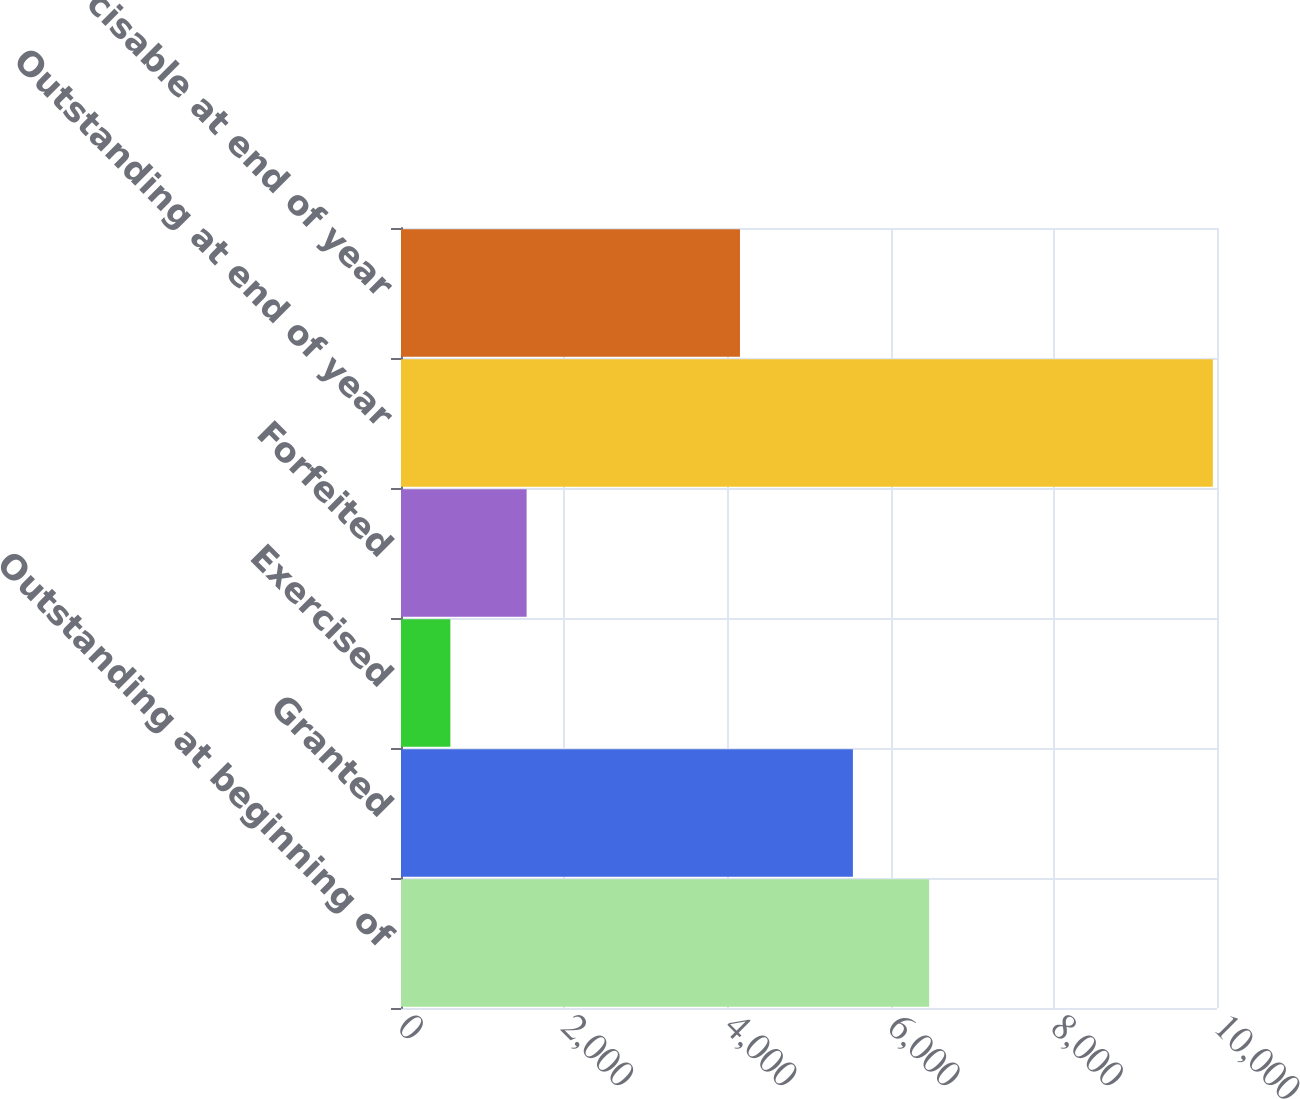Convert chart. <chart><loc_0><loc_0><loc_500><loc_500><bar_chart><fcel>Outstanding at beginning of<fcel>Granted<fcel>Exercised<fcel>Forfeited<fcel>Outstanding at end of year<fcel>Exercisable at end of year<nl><fcel>6472.4<fcel>5538<fcel>605<fcel>1539.4<fcel>9949<fcel>4154<nl></chart> 